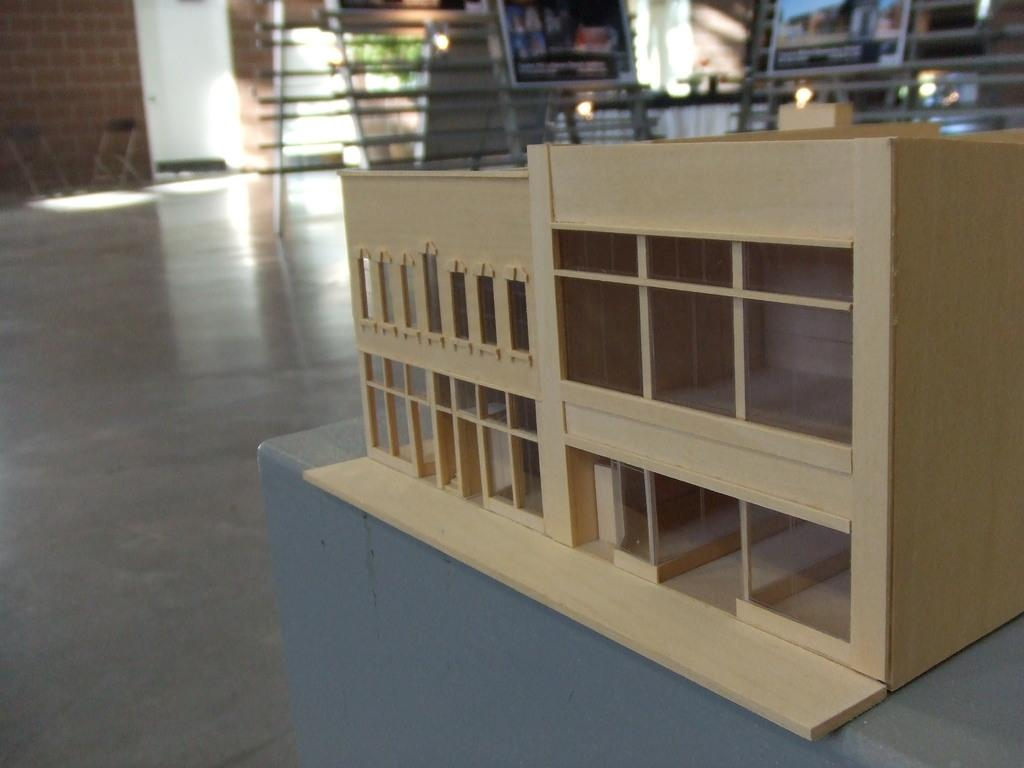What type of toy is on the table in the image? There is a wooden toy building on the table in the image. Where was the image taken? The image was taken inside a room. What can be seen in the background of the image? There are paintings on a stand and a brick wall on the left side of the background. What type of instrument is being played by the person wearing a skirt in the image? There is no person wearing a skirt or playing an instrument in the image. 